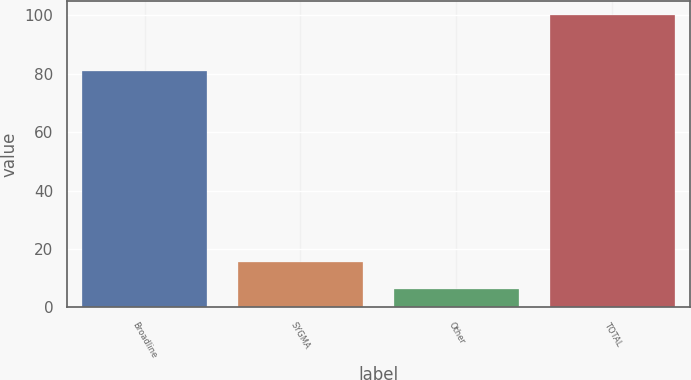Convert chart. <chart><loc_0><loc_0><loc_500><loc_500><bar_chart><fcel>Broadline<fcel>SYGMA<fcel>Other<fcel>TOTAL<nl><fcel>81<fcel>15.67<fcel>6.3<fcel>100<nl></chart> 